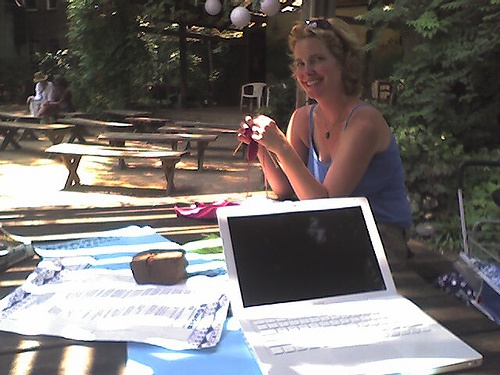Describe the objects in this image and their specific colors. I can see laptop in black, white, darkgray, and lightgray tones, people in black, brown, and maroon tones, bench in black, white, gray, and maroon tones, bench in black and gray tones, and bench in black and gray tones in this image. 